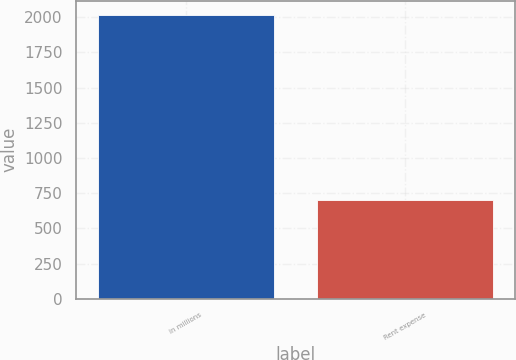<chart> <loc_0><loc_0><loc_500><loc_500><bar_chart><fcel>in millions<fcel>Rent expense<nl><fcel>2017<fcel>704<nl></chart> 